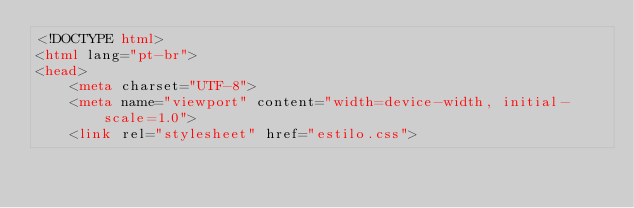<code> <loc_0><loc_0><loc_500><loc_500><_HTML_><!DOCTYPE html>
<html lang="pt-br">
<head>
    <meta charset="UTF-8">
    <meta name="viewport" content="width=device-width, initial-scale=1.0">
    <link rel="stylesheet" href="estilo.css"></code> 